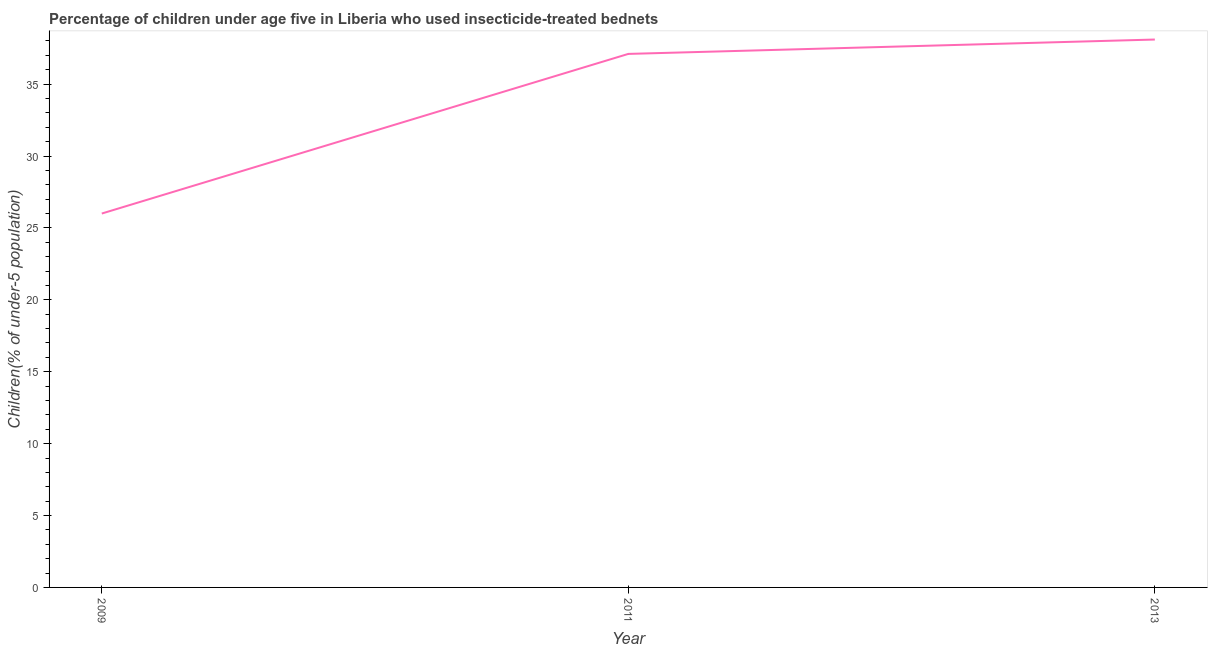What is the percentage of children who use of insecticide-treated bed nets in 2013?
Provide a succinct answer. 38.1. Across all years, what is the maximum percentage of children who use of insecticide-treated bed nets?
Give a very brief answer. 38.1. Across all years, what is the minimum percentage of children who use of insecticide-treated bed nets?
Offer a terse response. 26. In which year was the percentage of children who use of insecticide-treated bed nets minimum?
Provide a succinct answer. 2009. What is the sum of the percentage of children who use of insecticide-treated bed nets?
Offer a terse response. 101.2. What is the difference between the percentage of children who use of insecticide-treated bed nets in 2009 and 2011?
Your response must be concise. -11.1. What is the average percentage of children who use of insecticide-treated bed nets per year?
Your answer should be compact. 33.73. What is the median percentage of children who use of insecticide-treated bed nets?
Keep it short and to the point. 37.1. What is the ratio of the percentage of children who use of insecticide-treated bed nets in 2011 to that in 2013?
Offer a terse response. 0.97. Is the percentage of children who use of insecticide-treated bed nets in 2011 less than that in 2013?
Your response must be concise. Yes. Is the difference between the percentage of children who use of insecticide-treated bed nets in 2009 and 2013 greater than the difference between any two years?
Provide a succinct answer. Yes. What is the difference between the highest and the lowest percentage of children who use of insecticide-treated bed nets?
Offer a terse response. 12.1. Does the percentage of children who use of insecticide-treated bed nets monotonically increase over the years?
Offer a very short reply. Yes. How many years are there in the graph?
Offer a terse response. 3. What is the difference between two consecutive major ticks on the Y-axis?
Your answer should be compact. 5. Are the values on the major ticks of Y-axis written in scientific E-notation?
Offer a terse response. No. What is the title of the graph?
Make the answer very short. Percentage of children under age five in Liberia who used insecticide-treated bednets. What is the label or title of the Y-axis?
Your response must be concise. Children(% of under-5 population). What is the Children(% of under-5 population) of 2011?
Give a very brief answer. 37.1. What is the Children(% of under-5 population) of 2013?
Ensure brevity in your answer.  38.1. What is the difference between the Children(% of under-5 population) in 2009 and 2013?
Your response must be concise. -12.1. What is the ratio of the Children(% of under-5 population) in 2009 to that in 2011?
Your response must be concise. 0.7. What is the ratio of the Children(% of under-5 population) in 2009 to that in 2013?
Make the answer very short. 0.68. 